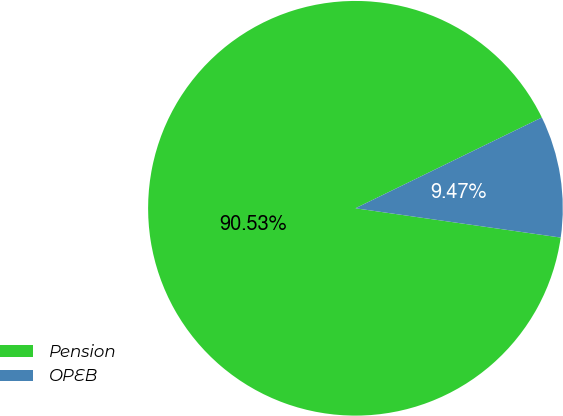Convert chart to OTSL. <chart><loc_0><loc_0><loc_500><loc_500><pie_chart><fcel>Pension<fcel>OPEB<nl><fcel>90.53%<fcel>9.47%<nl></chart> 